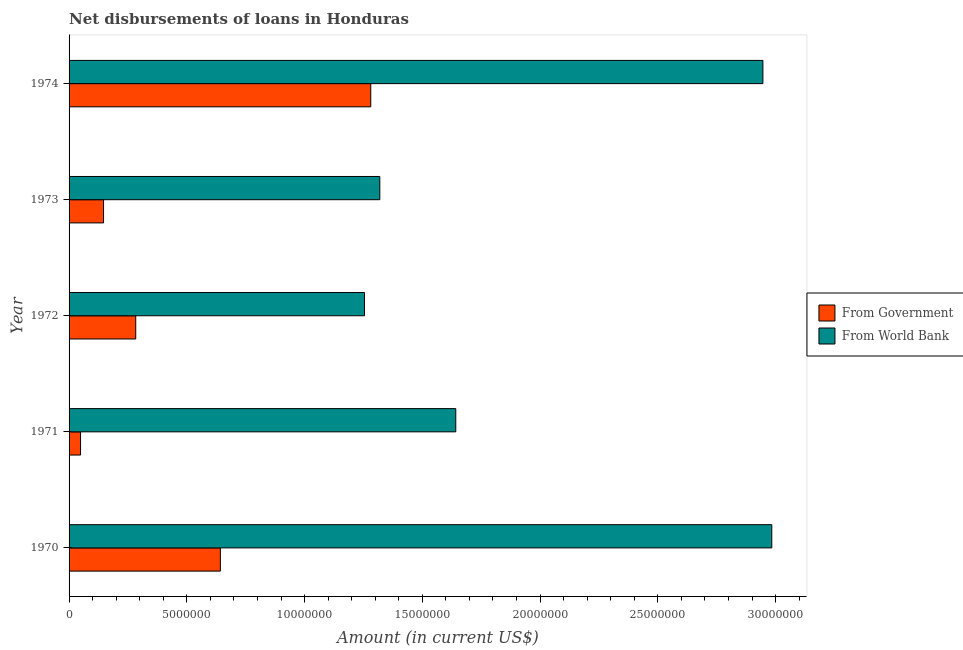How many different coloured bars are there?
Your answer should be very brief. 2. How many groups of bars are there?
Give a very brief answer. 5. Are the number of bars per tick equal to the number of legend labels?
Give a very brief answer. Yes. How many bars are there on the 4th tick from the top?
Offer a very short reply. 2. How many bars are there on the 2nd tick from the bottom?
Keep it short and to the point. 2. In how many cases, is the number of bars for a given year not equal to the number of legend labels?
Offer a very short reply. 0. What is the net disbursements of loan from world bank in 1971?
Offer a very short reply. 1.64e+07. Across all years, what is the maximum net disbursements of loan from world bank?
Your answer should be very brief. 2.98e+07. Across all years, what is the minimum net disbursements of loan from government?
Provide a succinct answer. 4.87e+05. In which year was the net disbursements of loan from government maximum?
Offer a terse response. 1974. In which year was the net disbursements of loan from world bank minimum?
Your response must be concise. 1972. What is the total net disbursements of loan from world bank in the graph?
Provide a succinct answer. 1.01e+08. What is the difference between the net disbursements of loan from government in 1970 and that in 1974?
Give a very brief answer. -6.39e+06. What is the difference between the net disbursements of loan from world bank in 1973 and the net disbursements of loan from government in 1970?
Offer a terse response. 6.77e+06. What is the average net disbursements of loan from world bank per year?
Offer a very short reply. 2.03e+07. In the year 1972, what is the difference between the net disbursements of loan from government and net disbursements of loan from world bank?
Give a very brief answer. -9.71e+06. What is the ratio of the net disbursements of loan from world bank in 1972 to that in 1974?
Give a very brief answer. 0.43. Is the net disbursements of loan from government in 1971 less than that in 1973?
Your answer should be very brief. Yes. What is the difference between the highest and the second highest net disbursements of loan from government?
Make the answer very short. 6.39e+06. What is the difference between the highest and the lowest net disbursements of loan from world bank?
Keep it short and to the point. 1.73e+07. In how many years, is the net disbursements of loan from world bank greater than the average net disbursements of loan from world bank taken over all years?
Offer a terse response. 2. Is the sum of the net disbursements of loan from world bank in 1972 and 1973 greater than the maximum net disbursements of loan from government across all years?
Give a very brief answer. Yes. What does the 2nd bar from the top in 1973 represents?
Your answer should be very brief. From Government. What does the 2nd bar from the bottom in 1970 represents?
Provide a succinct answer. From World Bank. How many bars are there?
Make the answer very short. 10. Are all the bars in the graph horizontal?
Offer a very short reply. Yes. How many years are there in the graph?
Provide a succinct answer. 5. What is the difference between two consecutive major ticks on the X-axis?
Your response must be concise. 5.00e+06. Does the graph contain grids?
Offer a very short reply. No. Where does the legend appear in the graph?
Your answer should be very brief. Center right. How are the legend labels stacked?
Give a very brief answer. Vertical. What is the title of the graph?
Provide a short and direct response. Net disbursements of loans in Honduras. Does "Age 15+" appear as one of the legend labels in the graph?
Provide a succinct answer. No. What is the label or title of the X-axis?
Provide a short and direct response. Amount (in current US$). What is the Amount (in current US$) of From Government in 1970?
Provide a succinct answer. 6.42e+06. What is the Amount (in current US$) of From World Bank in 1970?
Offer a very short reply. 2.98e+07. What is the Amount (in current US$) in From Government in 1971?
Offer a terse response. 4.87e+05. What is the Amount (in current US$) in From World Bank in 1971?
Give a very brief answer. 1.64e+07. What is the Amount (in current US$) of From Government in 1972?
Your answer should be very brief. 2.83e+06. What is the Amount (in current US$) of From World Bank in 1972?
Offer a terse response. 1.25e+07. What is the Amount (in current US$) of From Government in 1973?
Provide a short and direct response. 1.46e+06. What is the Amount (in current US$) of From World Bank in 1973?
Provide a short and direct response. 1.32e+07. What is the Amount (in current US$) in From Government in 1974?
Keep it short and to the point. 1.28e+07. What is the Amount (in current US$) in From World Bank in 1974?
Ensure brevity in your answer.  2.95e+07. Across all years, what is the maximum Amount (in current US$) of From Government?
Offer a very short reply. 1.28e+07. Across all years, what is the maximum Amount (in current US$) in From World Bank?
Provide a succinct answer. 2.98e+07. Across all years, what is the minimum Amount (in current US$) of From Government?
Your answer should be compact. 4.87e+05. Across all years, what is the minimum Amount (in current US$) in From World Bank?
Your response must be concise. 1.25e+07. What is the total Amount (in current US$) of From Government in the graph?
Ensure brevity in your answer.  2.40e+07. What is the total Amount (in current US$) in From World Bank in the graph?
Your answer should be compact. 1.01e+08. What is the difference between the Amount (in current US$) of From Government in 1970 and that in 1971?
Give a very brief answer. 5.94e+06. What is the difference between the Amount (in current US$) of From World Bank in 1970 and that in 1971?
Offer a very short reply. 1.34e+07. What is the difference between the Amount (in current US$) in From Government in 1970 and that in 1972?
Provide a succinct answer. 3.59e+06. What is the difference between the Amount (in current US$) of From World Bank in 1970 and that in 1972?
Ensure brevity in your answer.  1.73e+07. What is the difference between the Amount (in current US$) of From Government in 1970 and that in 1973?
Offer a terse response. 4.96e+06. What is the difference between the Amount (in current US$) of From World Bank in 1970 and that in 1973?
Offer a very short reply. 1.66e+07. What is the difference between the Amount (in current US$) of From Government in 1970 and that in 1974?
Keep it short and to the point. -6.39e+06. What is the difference between the Amount (in current US$) of From World Bank in 1970 and that in 1974?
Provide a succinct answer. 3.78e+05. What is the difference between the Amount (in current US$) of From Government in 1971 and that in 1972?
Give a very brief answer. -2.34e+06. What is the difference between the Amount (in current US$) in From World Bank in 1971 and that in 1972?
Keep it short and to the point. 3.88e+06. What is the difference between the Amount (in current US$) of From Government in 1971 and that in 1973?
Ensure brevity in your answer.  -9.77e+05. What is the difference between the Amount (in current US$) in From World Bank in 1971 and that in 1973?
Make the answer very short. 3.23e+06. What is the difference between the Amount (in current US$) in From Government in 1971 and that in 1974?
Ensure brevity in your answer.  -1.23e+07. What is the difference between the Amount (in current US$) in From World Bank in 1971 and that in 1974?
Your answer should be very brief. -1.30e+07. What is the difference between the Amount (in current US$) of From Government in 1972 and that in 1973?
Offer a terse response. 1.37e+06. What is the difference between the Amount (in current US$) of From World Bank in 1972 and that in 1973?
Your response must be concise. -6.51e+05. What is the difference between the Amount (in current US$) of From Government in 1972 and that in 1974?
Provide a succinct answer. -9.98e+06. What is the difference between the Amount (in current US$) of From World Bank in 1972 and that in 1974?
Your answer should be compact. -1.69e+07. What is the difference between the Amount (in current US$) in From Government in 1973 and that in 1974?
Keep it short and to the point. -1.13e+07. What is the difference between the Amount (in current US$) in From World Bank in 1973 and that in 1974?
Your answer should be compact. -1.63e+07. What is the difference between the Amount (in current US$) in From Government in 1970 and the Amount (in current US$) in From World Bank in 1971?
Offer a very short reply. -1.00e+07. What is the difference between the Amount (in current US$) in From Government in 1970 and the Amount (in current US$) in From World Bank in 1972?
Give a very brief answer. -6.12e+06. What is the difference between the Amount (in current US$) of From Government in 1970 and the Amount (in current US$) of From World Bank in 1973?
Make the answer very short. -6.77e+06. What is the difference between the Amount (in current US$) of From Government in 1970 and the Amount (in current US$) of From World Bank in 1974?
Provide a short and direct response. -2.30e+07. What is the difference between the Amount (in current US$) of From Government in 1971 and the Amount (in current US$) of From World Bank in 1972?
Keep it short and to the point. -1.21e+07. What is the difference between the Amount (in current US$) in From Government in 1971 and the Amount (in current US$) in From World Bank in 1973?
Ensure brevity in your answer.  -1.27e+07. What is the difference between the Amount (in current US$) in From Government in 1971 and the Amount (in current US$) in From World Bank in 1974?
Your response must be concise. -2.90e+07. What is the difference between the Amount (in current US$) of From Government in 1972 and the Amount (in current US$) of From World Bank in 1973?
Make the answer very short. -1.04e+07. What is the difference between the Amount (in current US$) of From Government in 1972 and the Amount (in current US$) of From World Bank in 1974?
Ensure brevity in your answer.  -2.66e+07. What is the difference between the Amount (in current US$) in From Government in 1973 and the Amount (in current US$) in From World Bank in 1974?
Give a very brief answer. -2.80e+07. What is the average Amount (in current US$) of From Government per year?
Your answer should be compact. 4.80e+06. What is the average Amount (in current US$) of From World Bank per year?
Provide a succinct answer. 2.03e+07. In the year 1970, what is the difference between the Amount (in current US$) in From Government and Amount (in current US$) in From World Bank?
Ensure brevity in your answer.  -2.34e+07. In the year 1971, what is the difference between the Amount (in current US$) of From Government and Amount (in current US$) of From World Bank?
Make the answer very short. -1.59e+07. In the year 1972, what is the difference between the Amount (in current US$) in From Government and Amount (in current US$) in From World Bank?
Offer a very short reply. -9.71e+06. In the year 1973, what is the difference between the Amount (in current US$) of From Government and Amount (in current US$) of From World Bank?
Give a very brief answer. -1.17e+07. In the year 1974, what is the difference between the Amount (in current US$) of From Government and Amount (in current US$) of From World Bank?
Provide a short and direct response. -1.67e+07. What is the ratio of the Amount (in current US$) in From Government in 1970 to that in 1971?
Offer a terse response. 13.19. What is the ratio of the Amount (in current US$) in From World Bank in 1970 to that in 1971?
Offer a terse response. 1.82. What is the ratio of the Amount (in current US$) of From Government in 1970 to that in 1972?
Provide a short and direct response. 2.27. What is the ratio of the Amount (in current US$) of From World Bank in 1970 to that in 1972?
Your answer should be very brief. 2.38. What is the ratio of the Amount (in current US$) of From Government in 1970 to that in 1973?
Keep it short and to the point. 4.39. What is the ratio of the Amount (in current US$) of From World Bank in 1970 to that in 1973?
Your answer should be very brief. 2.26. What is the ratio of the Amount (in current US$) of From Government in 1970 to that in 1974?
Offer a terse response. 0.5. What is the ratio of the Amount (in current US$) of From World Bank in 1970 to that in 1974?
Keep it short and to the point. 1.01. What is the ratio of the Amount (in current US$) of From Government in 1971 to that in 1972?
Offer a terse response. 0.17. What is the ratio of the Amount (in current US$) of From World Bank in 1971 to that in 1972?
Your response must be concise. 1.31. What is the ratio of the Amount (in current US$) of From Government in 1971 to that in 1973?
Provide a succinct answer. 0.33. What is the ratio of the Amount (in current US$) in From World Bank in 1971 to that in 1973?
Offer a terse response. 1.24. What is the ratio of the Amount (in current US$) of From Government in 1971 to that in 1974?
Ensure brevity in your answer.  0.04. What is the ratio of the Amount (in current US$) in From World Bank in 1971 to that in 1974?
Your answer should be very brief. 0.56. What is the ratio of the Amount (in current US$) in From Government in 1972 to that in 1973?
Your response must be concise. 1.93. What is the ratio of the Amount (in current US$) in From World Bank in 1972 to that in 1973?
Your answer should be compact. 0.95. What is the ratio of the Amount (in current US$) in From Government in 1972 to that in 1974?
Make the answer very short. 0.22. What is the ratio of the Amount (in current US$) of From World Bank in 1972 to that in 1974?
Your response must be concise. 0.43. What is the ratio of the Amount (in current US$) of From Government in 1973 to that in 1974?
Your answer should be compact. 0.11. What is the ratio of the Amount (in current US$) of From World Bank in 1973 to that in 1974?
Provide a short and direct response. 0.45. What is the difference between the highest and the second highest Amount (in current US$) in From Government?
Provide a short and direct response. 6.39e+06. What is the difference between the highest and the second highest Amount (in current US$) of From World Bank?
Offer a terse response. 3.78e+05. What is the difference between the highest and the lowest Amount (in current US$) in From Government?
Your answer should be very brief. 1.23e+07. What is the difference between the highest and the lowest Amount (in current US$) of From World Bank?
Your answer should be compact. 1.73e+07. 